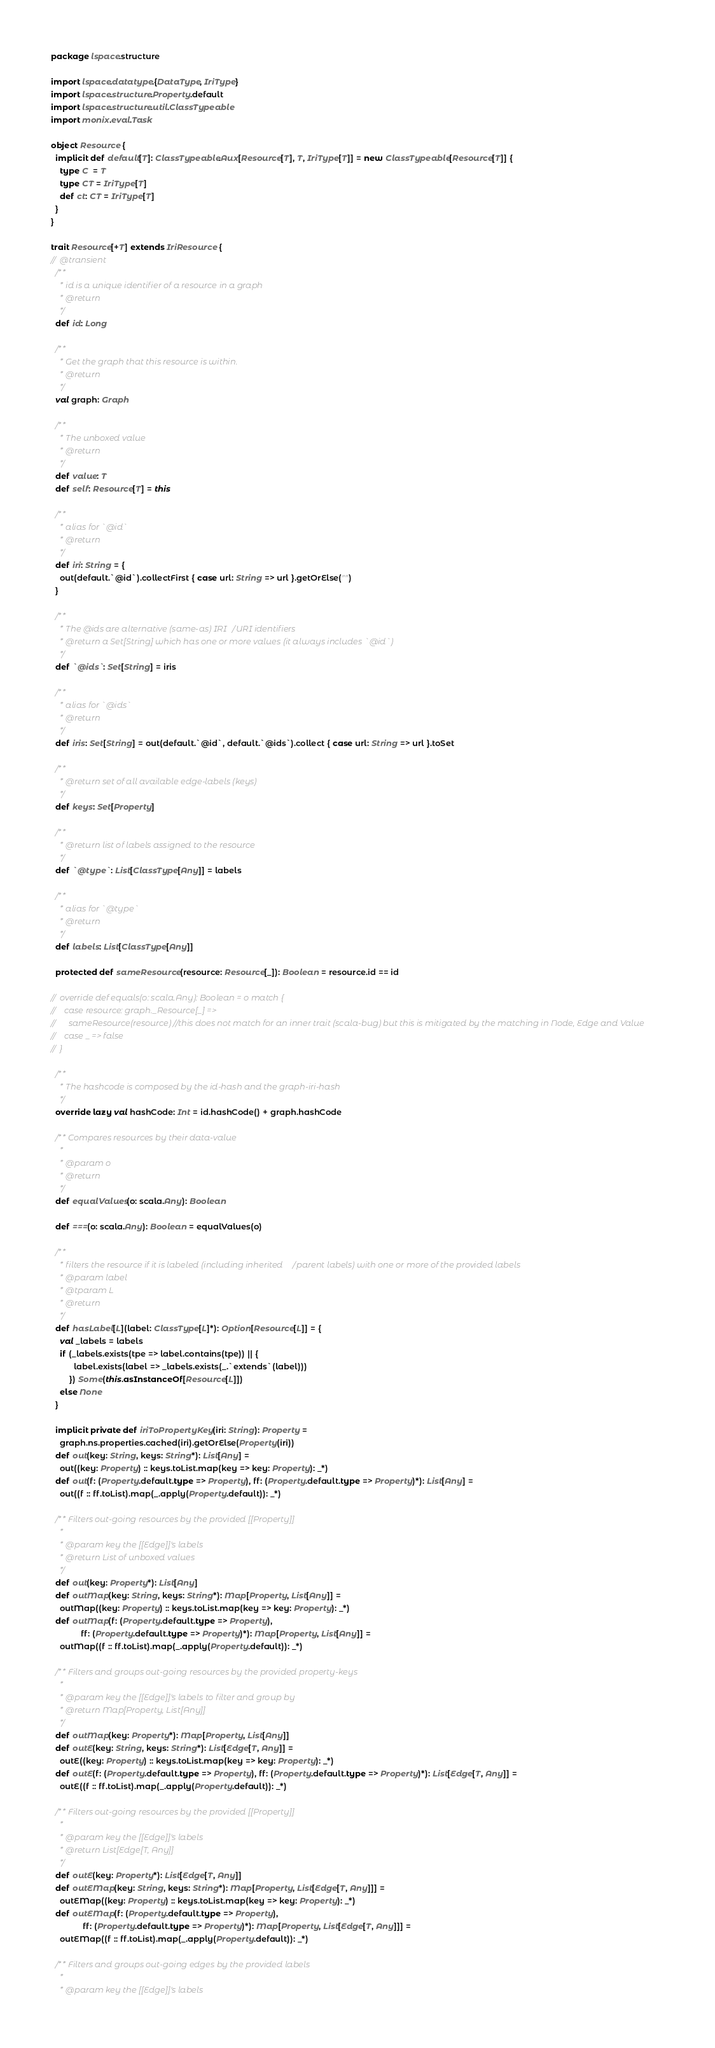Convert code to text. <code><loc_0><loc_0><loc_500><loc_500><_Scala_>package lspace.structure

import lspace.datatype.{DataType, IriType}
import lspace.structure.Property.default
import lspace.structure.util.ClassTypeable
import monix.eval.Task

object Resource {
  implicit def default[T]: ClassTypeable.Aux[Resource[T], T, IriType[T]] = new ClassTypeable[Resource[T]] {
    type C  = T
    type CT = IriType[T]
    def ct: CT = IriType[T]
  }
}

trait Resource[+T] extends IriResource {
//  @transient
  /**
    * id is a unique identifier of a resource in a graph
    * @return
    */
  def id: Long

  /**
    * Get the graph that this resource is within.
    * @return
    */
  val graph: Graph

  /**
    * The unboxed value
    * @return
    */
  def value: T
  def self: Resource[T] = this

  /**
    * alias for `@id`
    * @return
    */
  def iri: String = {
    out(default.`@id`).collectFirst { case url: String => url }.getOrElse("")
  }

  /**
    * The @ids are alternative (same-as) IRI/URI identifiers
    * @return a Set[String] which has one or more values (it always includes `@id`)
    */
  def `@ids`: Set[String] = iris

  /**
    * alias for `@ids`
    * @return
    */
  def iris: Set[String] = out(default.`@id`, default.`@ids`).collect { case url: String => url }.toSet

  /**
    * @return set of all available edge-labels (keys)
    */
  def keys: Set[Property]

  /**
    * @return list of labels assigned to the resource
    */
  def `@type`: List[ClassType[Any]] = labels

  /**
    * alias for `@type`
    * @return
    */
  def labels: List[ClassType[Any]]

  protected def sameResource(resource: Resource[_]): Boolean = resource.id == id

//  override def equals(o: scala.Any): Boolean = o match {
//    case resource: graph._Resource[_] =>
//      sameResource(resource) //this does not match for an inner trait (scala-bug) but this is mitigated by the matching in Node, Edge and Value
//    case _ => false
//  }

  /**
    * The hashcode is composed by the id-hash and the graph-iri-hash
    */
  override lazy val hashCode: Int = id.hashCode() + graph.hashCode

  /** Compares resources by their data-value
    *
    * @param o
    * @return
    */
  def equalValues(o: scala.Any): Boolean

  def ===(o: scala.Any): Boolean = equalValues(o)

  /**
    * filters the resource if it is labeled (including inherited/parent labels) with one or more of the provided labels
    * @param label
    * @tparam L
    * @return
    */
  def hasLabel[L](label: ClassType[L]*): Option[Resource[L]] = {
    val _labels = labels
    if (_labels.exists(tpe => label.contains(tpe)) || {
          label.exists(label => _labels.exists(_.`extends`(label)))
        }) Some(this.asInstanceOf[Resource[L]])
    else None
  }

  implicit private def iriToPropertyKey(iri: String): Property =
    graph.ns.properties.cached(iri).getOrElse(Property(iri))
  def out(key: String, keys: String*): List[Any] =
    out((key: Property) :: keys.toList.map(key => key: Property): _*)
  def out(f: (Property.default.type => Property), ff: (Property.default.type => Property)*): List[Any] =
    out((f :: ff.toList).map(_.apply(Property.default)): _*)

  /** Filters out-going resources by the provided [[Property]]
    *
    * @param key the [[Edge]]'s labels
    * @return List of unboxed values
    */
  def out(key: Property*): List[Any]
  def outMap(key: String, keys: String*): Map[Property, List[Any]] =
    outMap((key: Property) :: keys.toList.map(key => key: Property): _*)
  def outMap(f: (Property.default.type => Property),
             ff: (Property.default.type => Property)*): Map[Property, List[Any]] =
    outMap((f :: ff.toList).map(_.apply(Property.default)): _*)

  /** Filters and groups out-going resources by the provided property-keys
    *
    * @param key the [[Edge]]'s labels to filter and group by
    * @return Map[Property, List[Any]]
    */
  def outMap(key: Property*): Map[Property, List[Any]]
  def outE(key: String, keys: String*): List[Edge[T, Any]] =
    outE((key: Property) :: keys.toList.map(key => key: Property): _*)
  def outE(f: (Property.default.type => Property), ff: (Property.default.type => Property)*): List[Edge[T, Any]] =
    outE((f :: ff.toList).map(_.apply(Property.default)): _*)

  /** Filters out-going resources by the provided [[Property]]
    *
    * @param key the [[Edge]]'s labels
    * @return List[Edge[T, Any]]
    */
  def outE(key: Property*): List[Edge[T, Any]]
  def outEMap(key: String, keys: String*): Map[Property, List[Edge[T, Any]]] =
    outEMap((key: Property) :: keys.toList.map(key => key: Property): _*)
  def outEMap(f: (Property.default.type => Property),
              ff: (Property.default.type => Property)*): Map[Property, List[Edge[T, Any]]] =
    outEMap((f :: ff.toList).map(_.apply(Property.default)): _*)

  /** Filters and groups out-going edges by the provided labels
    *
    * @param key the [[Edge]]'s labels</code> 